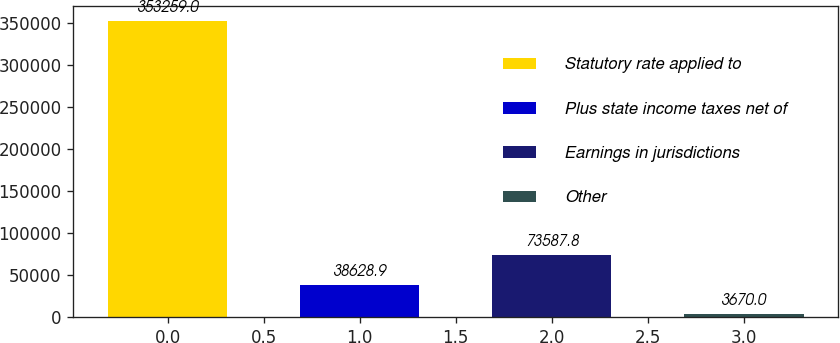Convert chart. <chart><loc_0><loc_0><loc_500><loc_500><bar_chart><fcel>Statutory rate applied to<fcel>Plus state income taxes net of<fcel>Earnings in jurisdictions<fcel>Other<nl><fcel>353259<fcel>38628.9<fcel>73587.8<fcel>3670<nl></chart> 